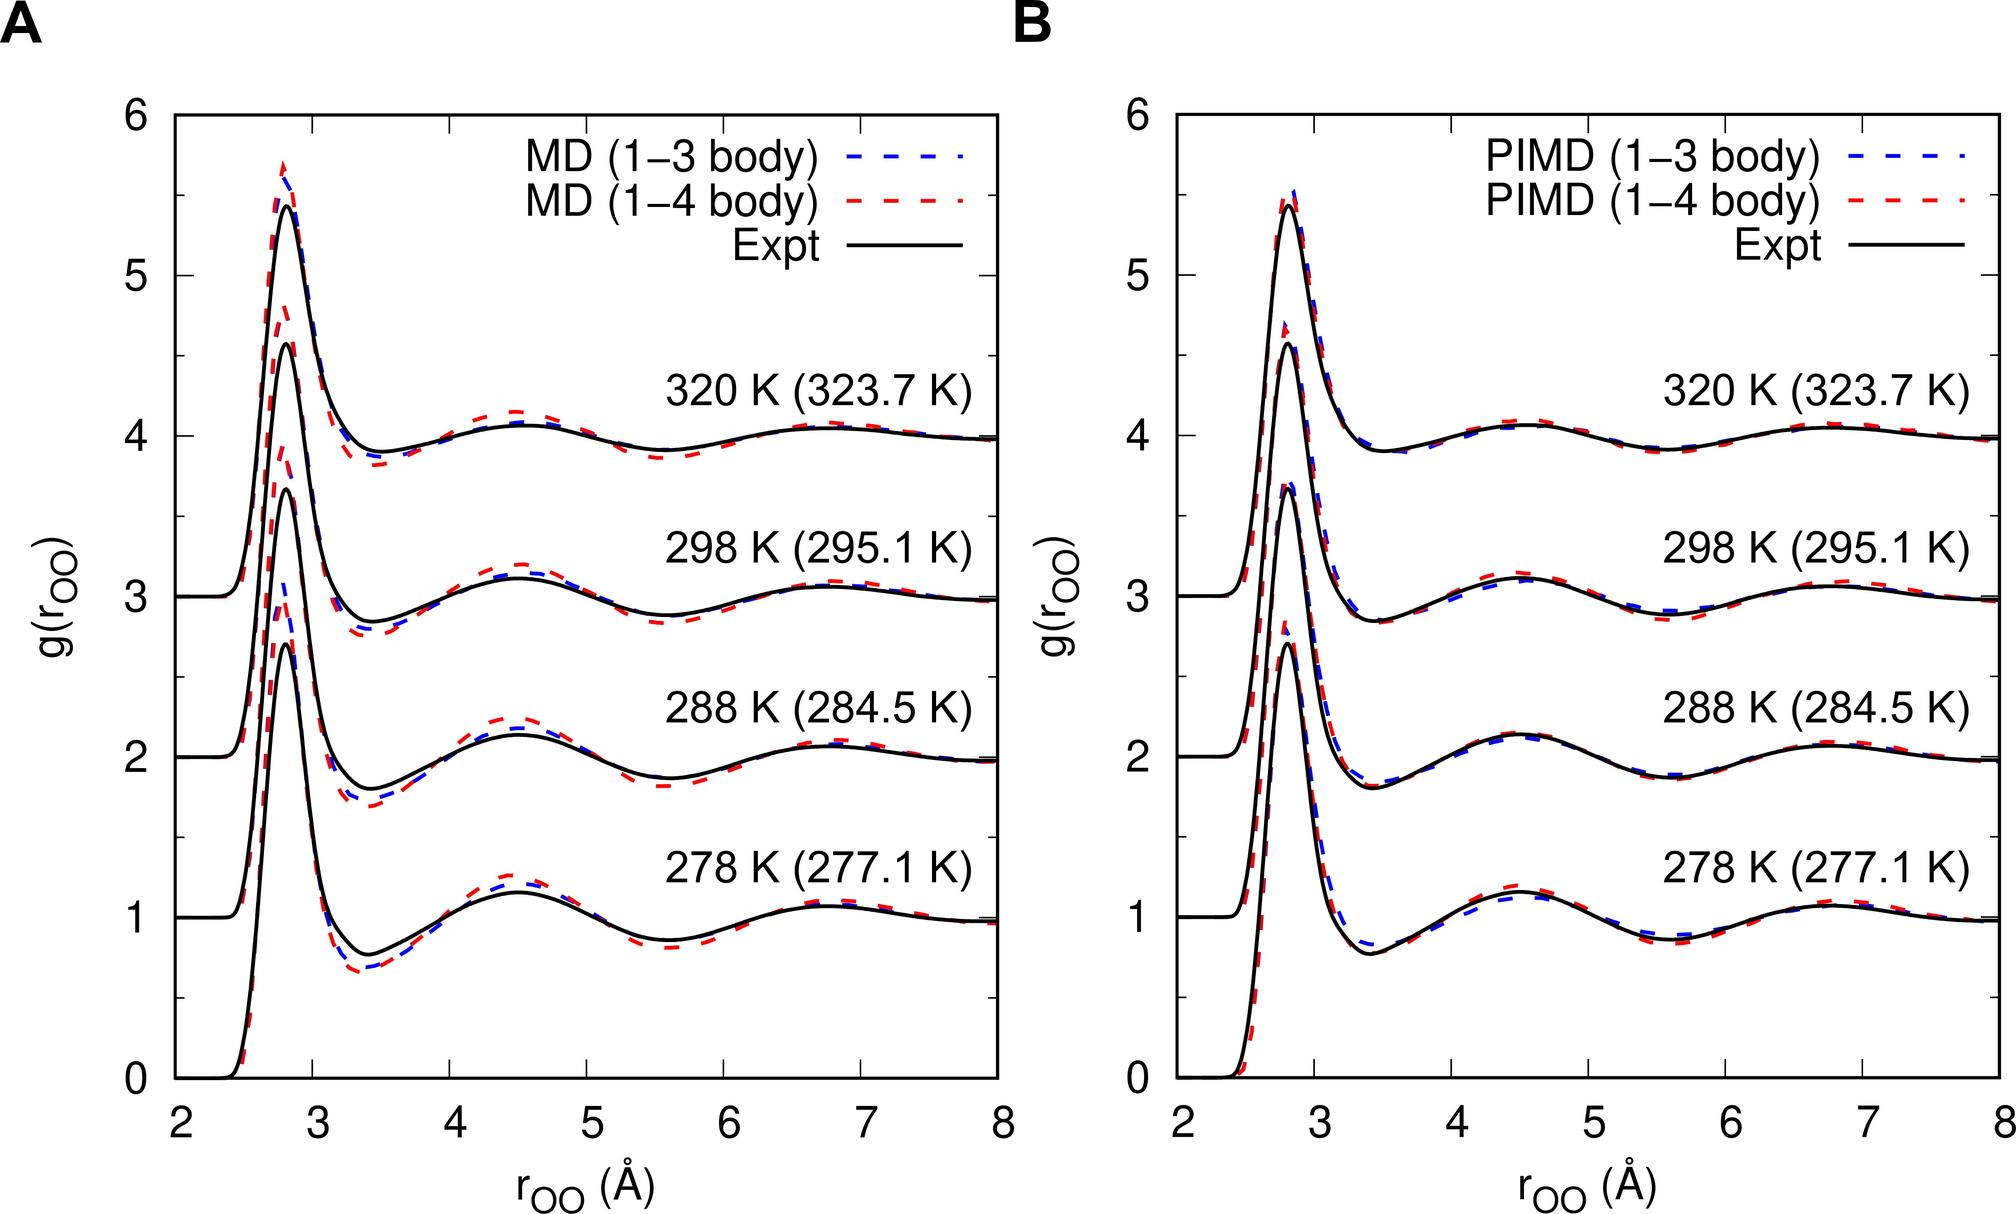Based on Figure B, which method shows a closer agreement with the experimental data for the first peak of g(r) at 298 K? MD (1-3 body) MD (1-4 body) PIMD (1-3 body) PIMD (1-4 body) - At 298 K, the PIMD (1-4 body) line is almost superimposed on the experimental data line, indicating that it agrees closely with the experimental results for the first peak of g(r). Therefore, the correct answer is D. 